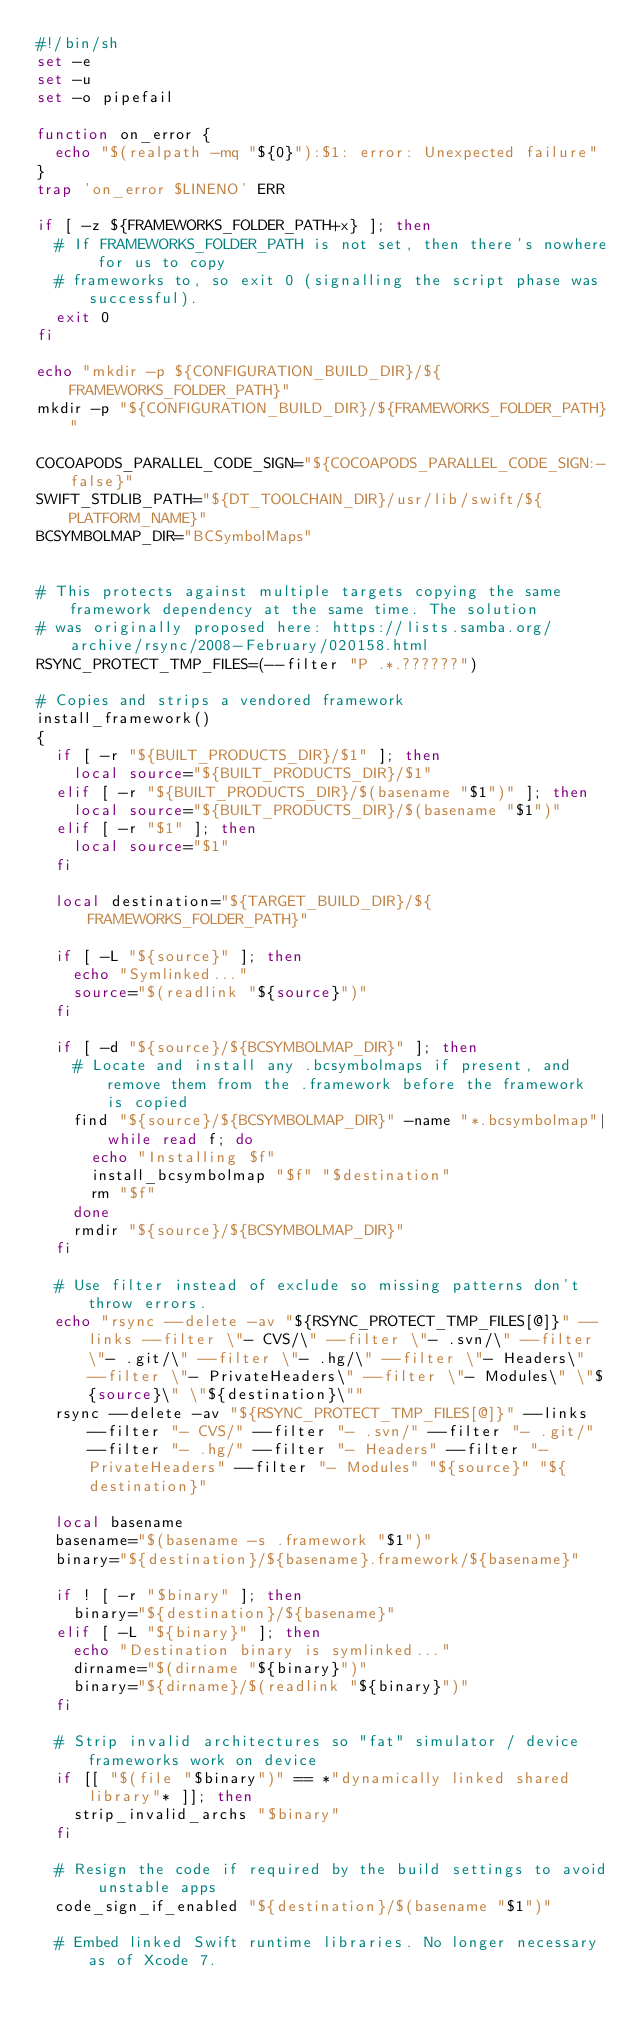Convert code to text. <code><loc_0><loc_0><loc_500><loc_500><_Bash_>#!/bin/sh
set -e
set -u
set -o pipefail

function on_error {
  echo "$(realpath -mq "${0}"):$1: error: Unexpected failure"
}
trap 'on_error $LINENO' ERR

if [ -z ${FRAMEWORKS_FOLDER_PATH+x} ]; then
  # If FRAMEWORKS_FOLDER_PATH is not set, then there's nowhere for us to copy
  # frameworks to, so exit 0 (signalling the script phase was successful).
  exit 0
fi

echo "mkdir -p ${CONFIGURATION_BUILD_DIR}/${FRAMEWORKS_FOLDER_PATH}"
mkdir -p "${CONFIGURATION_BUILD_DIR}/${FRAMEWORKS_FOLDER_PATH}"

COCOAPODS_PARALLEL_CODE_SIGN="${COCOAPODS_PARALLEL_CODE_SIGN:-false}"
SWIFT_STDLIB_PATH="${DT_TOOLCHAIN_DIR}/usr/lib/swift/${PLATFORM_NAME}"
BCSYMBOLMAP_DIR="BCSymbolMaps"


# This protects against multiple targets copying the same framework dependency at the same time. The solution
# was originally proposed here: https://lists.samba.org/archive/rsync/2008-February/020158.html
RSYNC_PROTECT_TMP_FILES=(--filter "P .*.??????")

# Copies and strips a vendored framework
install_framework()
{
  if [ -r "${BUILT_PRODUCTS_DIR}/$1" ]; then
    local source="${BUILT_PRODUCTS_DIR}/$1"
  elif [ -r "${BUILT_PRODUCTS_DIR}/$(basename "$1")" ]; then
    local source="${BUILT_PRODUCTS_DIR}/$(basename "$1")"
  elif [ -r "$1" ]; then
    local source="$1"
  fi

  local destination="${TARGET_BUILD_DIR}/${FRAMEWORKS_FOLDER_PATH}"

  if [ -L "${source}" ]; then
    echo "Symlinked..."
    source="$(readlink "${source}")"
  fi

  if [ -d "${source}/${BCSYMBOLMAP_DIR}" ]; then
    # Locate and install any .bcsymbolmaps if present, and remove them from the .framework before the framework is copied
    find "${source}/${BCSYMBOLMAP_DIR}" -name "*.bcsymbolmap"|while read f; do
      echo "Installing $f"
      install_bcsymbolmap "$f" "$destination"
      rm "$f"
    done
    rmdir "${source}/${BCSYMBOLMAP_DIR}"
  fi

  # Use filter instead of exclude so missing patterns don't throw errors.
  echo "rsync --delete -av "${RSYNC_PROTECT_TMP_FILES[@]}" --links --filter \"- CVS/\" --filter \"- .svn/\" --filter \"- .git/\" --filter \"- .hg/\" --filter \"- Headers\" --filter \"- PrivateHeaders\" --filter \"- Modules\" \"${source}\" \"${destination}\""
  rsync --delete -av "${RSYNC_PROTECT_TMP_FILES[@]}" --links --filter "- CVS/" --filter "- .svn/" --filter "- .git/" --filter "- .hg/" --filter "- Headers" --filter "- PrivateHeaders" --filter "- Modules" "${source}" "${destination}"

  local basename
  basename="$(basename -s .framework "$1")"
  binary="${destination}/${basename}.framework/${basename}"

  if ! [ -r "$binary" ]; then
    binary="${destination}/${basename}"
  elif [ -L "${binary}" ]; then
    echo "Destination binary is symlinked..."
    dirname="$(dirname "${binary}")"
    binary="${dirname}/$(readlink "${binary}")"
  fi

  # Strip invalid architectures so "fat" simulator / device frameworks work on device
  if [[ "$(file "$binary")" == *"dynamically linked shared library"* ]]; then
    strip_invalid_archs "$binary"
  fi

  # Resign the code if required by the build settings to avoid unstable apps
  code_sign_if_enabled "${destination}/$(basename "$1")"

  # Embed linked Swift runtime libraries. No longer necessary as of Xcode 7.</code> 